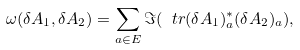Convert formula to latex. <formula><loc_0><loc_0><loc_500><loc_500>\omega ( \delta A _ { 1 } , \delta A _ { 2 } ) = \sum _ { a \in E } \Im ( \ t r ( \delta A _ { 1 } ) _ { a } ^ { * } ( \delta A _ { 2 } ) _ { a } ) ,</formula> 